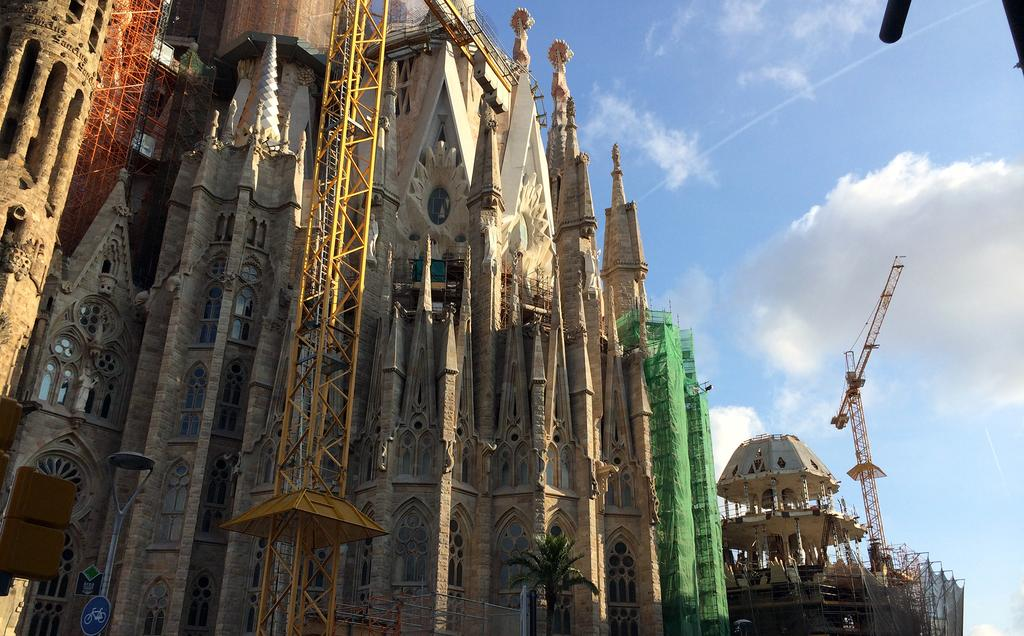What type of structures are present in the image? There are construction buildings in the image. What can be seen in the background of the image? The sky is visible behind the construction buildings. How many trees can be seen growing on the construction buildings in the image? There are no trees growing on the construction buildings in the image. 